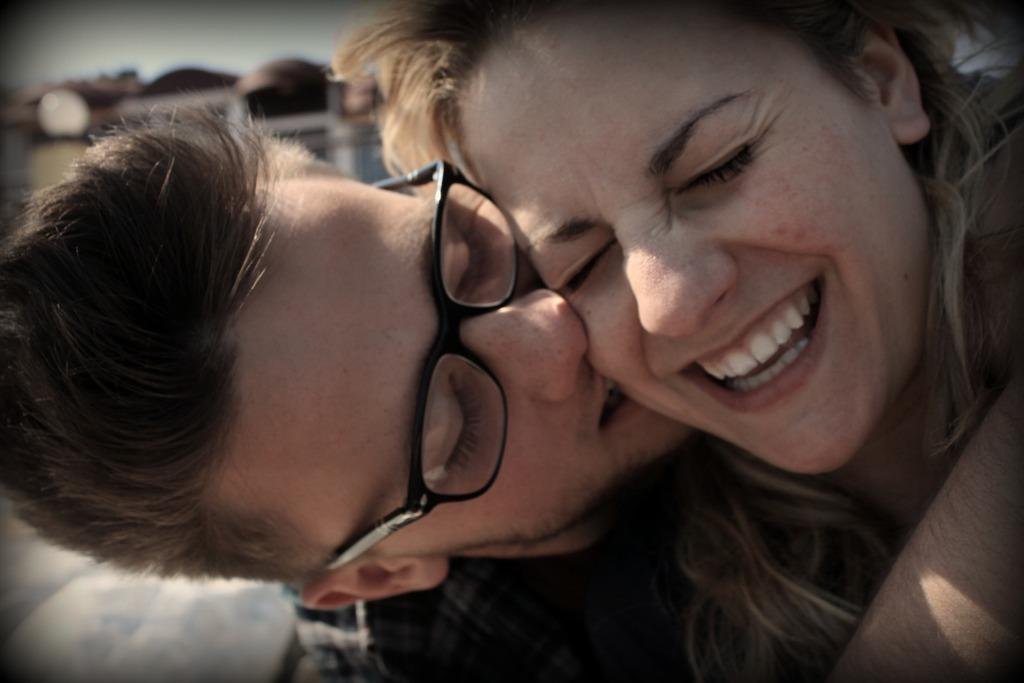Who are the people in the image? There is a man and a lady in the image. What can be observed about the man's appearance? The man is wearing glasses. How would you describe the background of the image? The background of the image is blurry. What type of beast can be seen in the image? There is no beast present in the image; it features a man and a lady. What is the lady's reaction to the man's nose in the image? There is no indication of the lady's reaction to the man's nose in the image, as it does not show any emotions or expressions. 